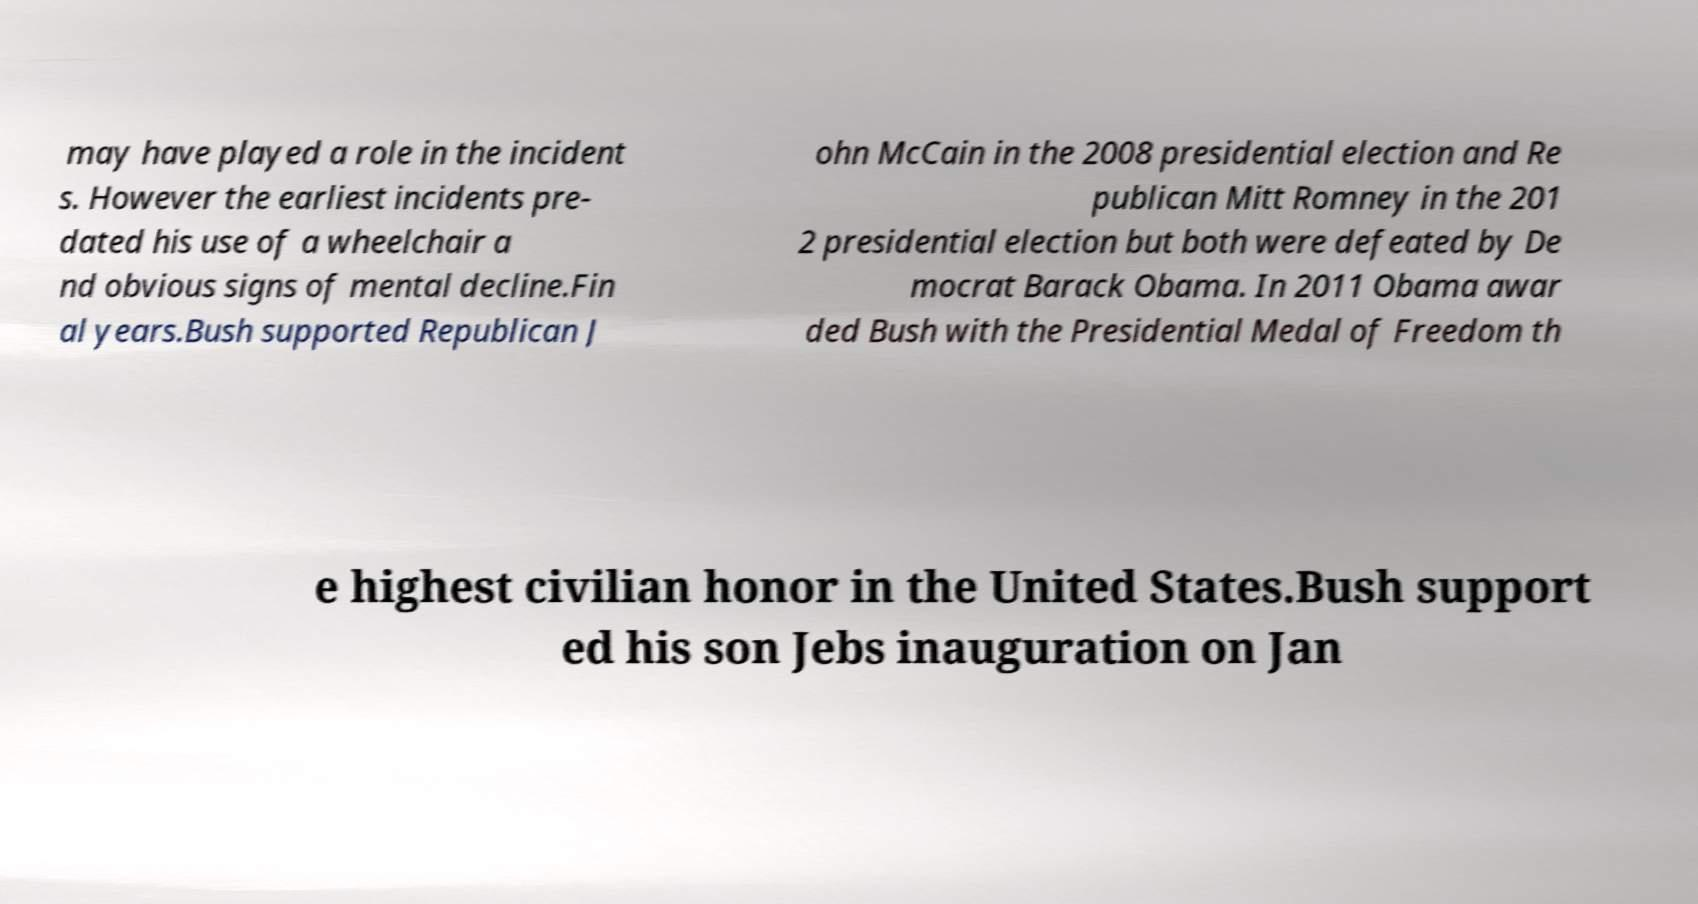What messages or text are displayed in this image? I need them in a readable, typed format. may have played a role in the incident s. However the earliest incidents pre- dated his use of a wheelchair a nd obvious signs of mental decline.Fin al years.Bush supported Republican J ohn McCain in the 2008 presidential election and Re publican Mitt Romney in the 201 2 presidential election but both were defeated by De mocrat Barack Obama. In 2011 Obama awar ded Bush with the Presidential Medal of Freedom th e highest civilian honor in the United States.Bush support ed his son Jebs inauguration on Jan 